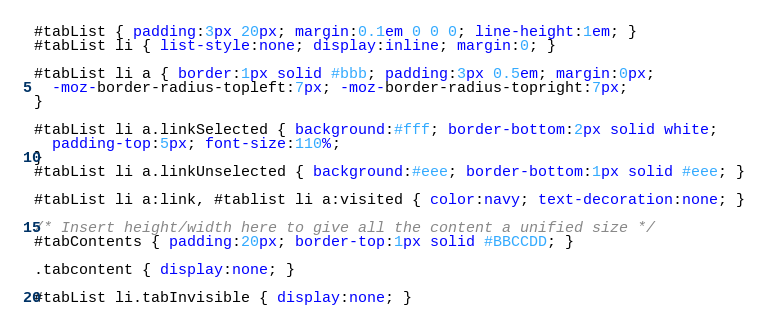<code> <loc_0><loc_0><loc_500><loc_500><_CSS_>
#tabList { padding:3px 20px; margin:0.1em 0 0 0; line-height:1em; }
#tabList li { list-style:none; display:inline; margin:0; }

#tabList li a { border:1px solid #bbb; padding:3px 0.5em; margin:0px;
  -moz-border-radius-topleft:7px; -moz-border-radius-topright:7px;
}

#tabList li a.linkSelected { background:#fff; border-bottom:2px solid white;
  padding-top:5px; font-size:110%;
}
#tabList li a.linkUnselected { background:#eee; border-bottom:1px solid #eee; }

#tabList li a:link, #tablist li a:visited { color:navy; text-decoration:none; }

/* Insert height/width here to give all the content a unified size */
#tabContents { padding:20px; border-top:1px solid #BBCCDD; }

.tabcontent { display:none; }

#tabList li.tabInvisible { display:none; }
</code> 